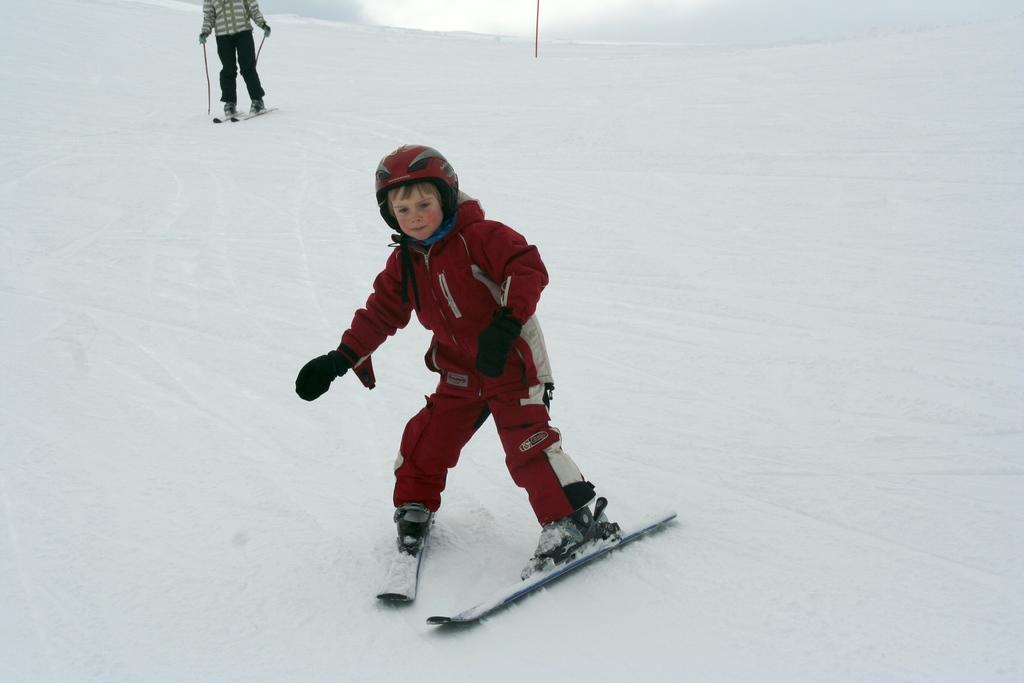Could you give a brief overview of what you see in this image? In the image in the center, we can see two persons are skiing on the snow. And the front person is wearing a helmet and gloves. In the background there is a pole and snow. 